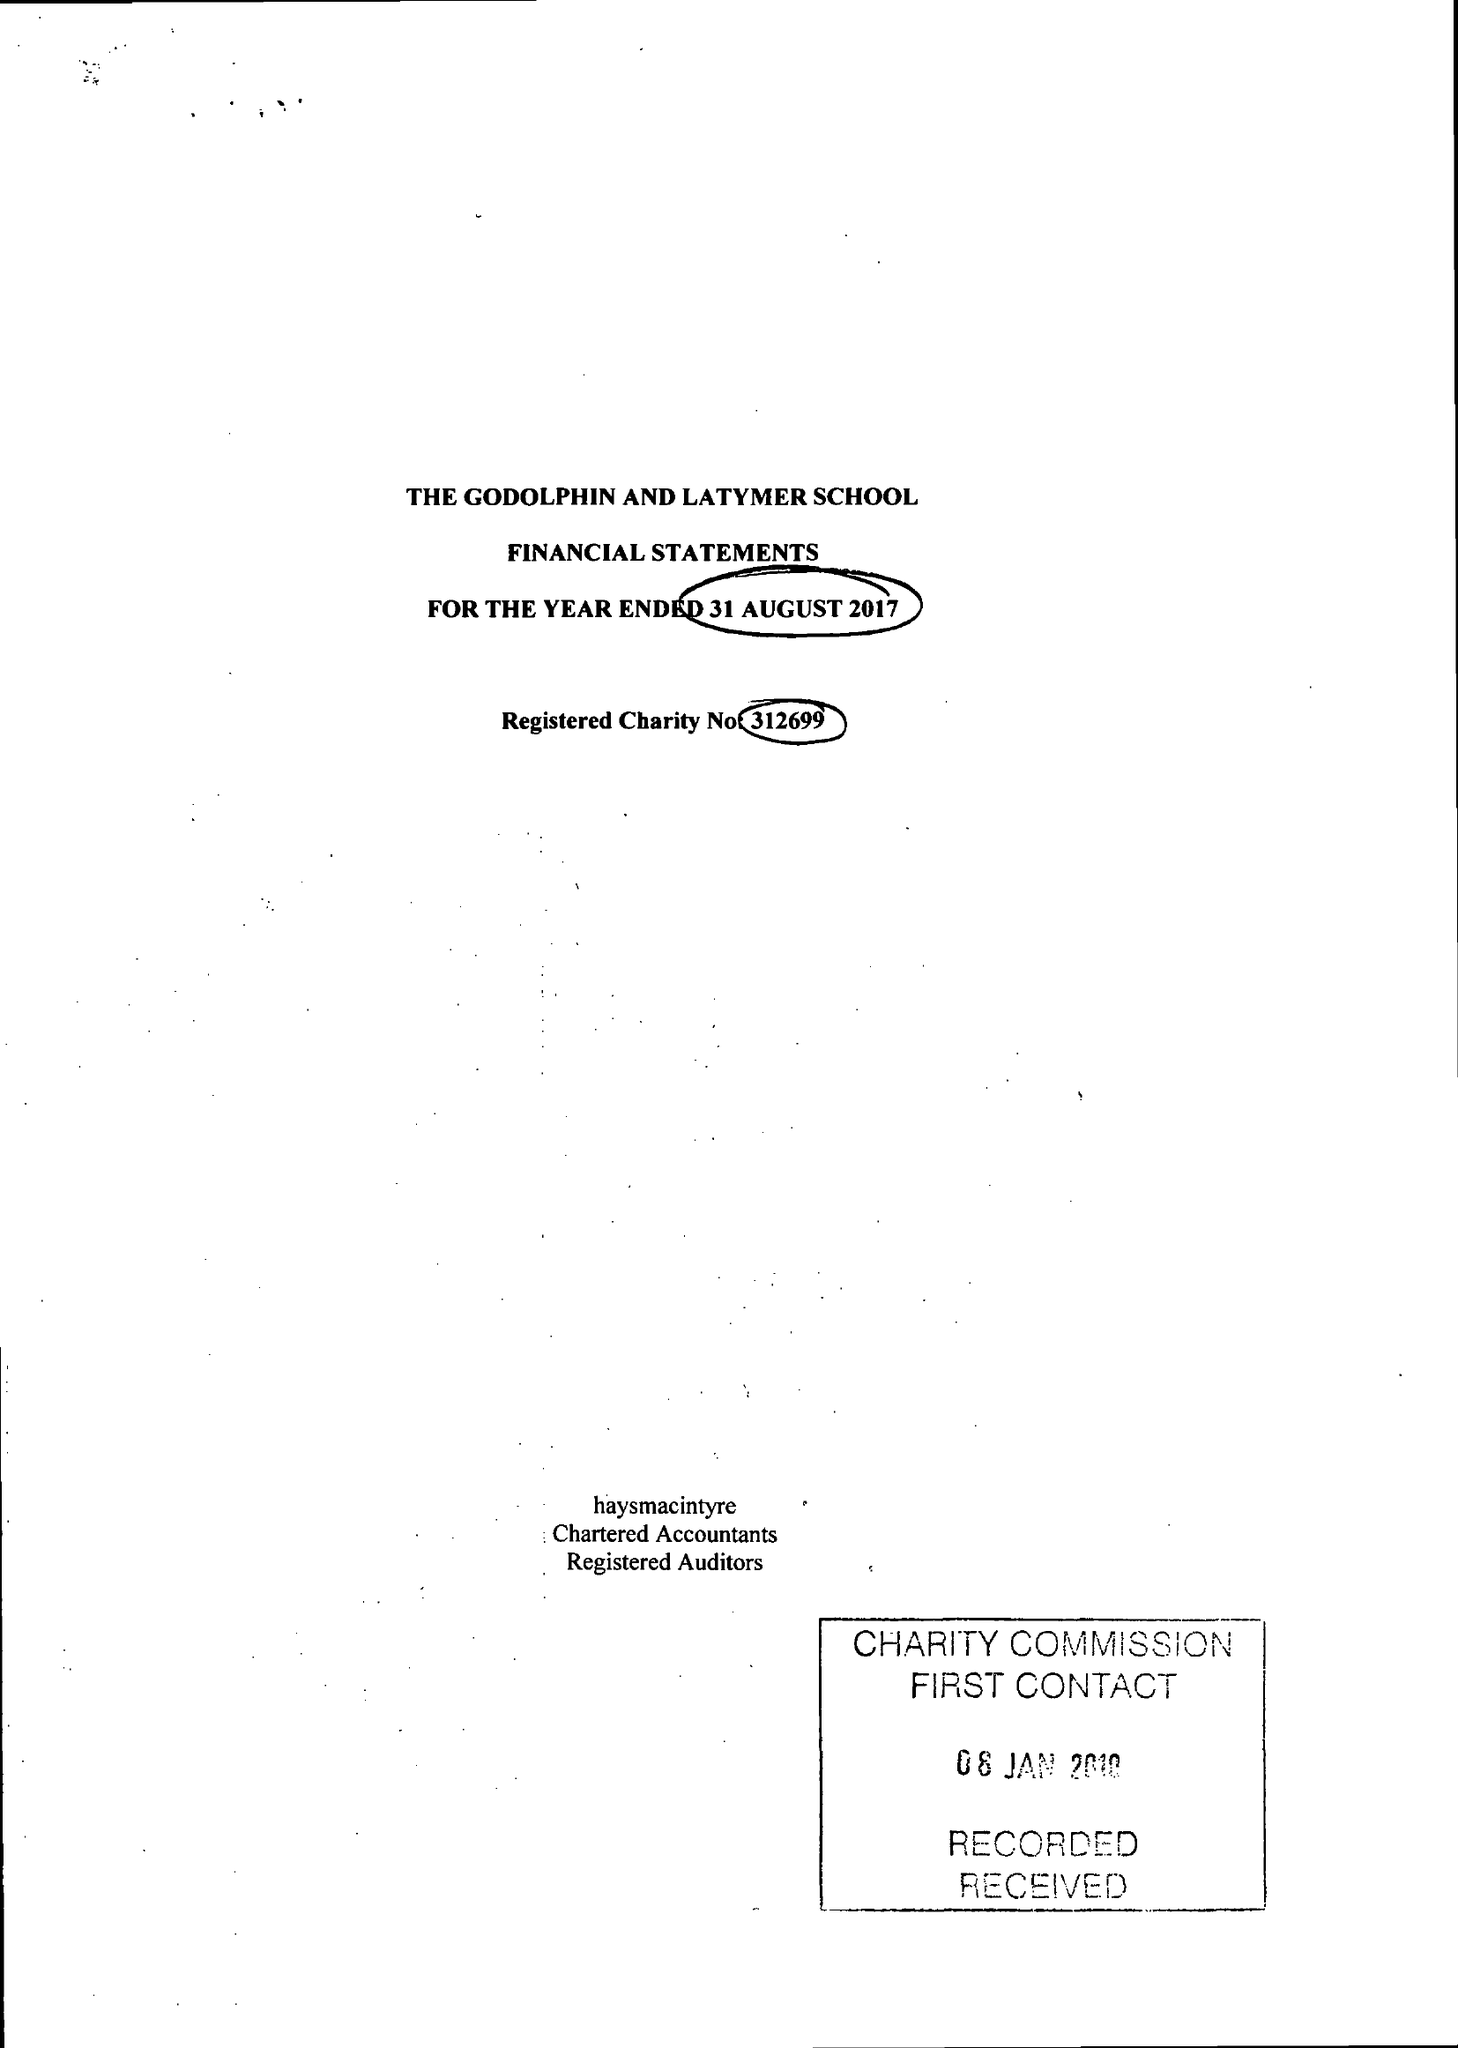What is the value for the charity_name?
Answer the question using a single word or phrase. Godolphin and Latymer School 